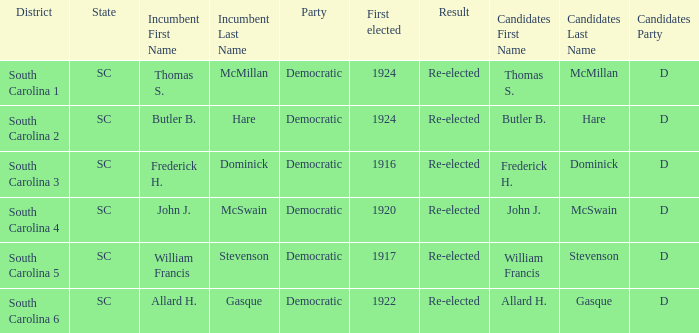What is the overall count of outcomes for the district south carolina 5? 1.0. 